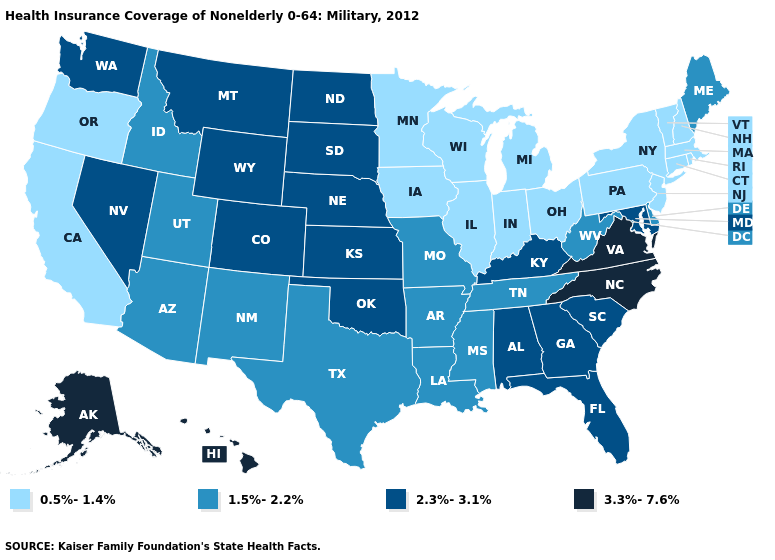Among the states that border Arkansas , does Oklahoma have the lowest value?
Short answer required. No. Does Michigan have the lowest value in the USA?
Be succinct. Yes. What is the value of Colorado?
Concise answer only. 2.3%-3.1%. Does the first symbol in the legend represent the smallest category?
Short answer required. Yes. What is the value of Ohio?
Quick response, please. 0.5%-1.4%. What is the value of Wisconsin?
Keep it brief. 0.5%-1.4%. Which states have the lowest value in the Northeast?
Keep it brief. Connecticut, Massachusetts, New Hampshire, New Jersey, New York, Pennsylvania, Rhode Island, Vermont. What is the value of Michigan?
Keep it brief. 0.5%-1.4%. Which states have the lowest value in the USA?
Quick response, please. California, Connecticut, Illinois, Indiana, Iowa, Massachusetts, Michigan, Minnesota, New Hampshire, New Jersey, New York, Ohio, Oregon, Pennsylvania, Rhode Island, Vermont, Wisconsin. Which states have the lowest value in the West?
Keep it brief. California, Oregon. What is the value of Utah?
Short answer required. 1.5%-2.2%. Name the states that have a value in the range 2.3%-3.1%?
Answer briefly. Alabama, Colorado, Florida, Georgia, Kansas, Kentucky, Maryland, Montana, Nebraska, Nevada, North Dakota, Oklahoma, South Carolina, South Dakota, Washington, Wyoming. What is the value of Alabama?
Give a very brief answer. 2.3%-3.1%. Does Maryland have the lowest value in the South?
Concise answer only. No. What is the lowest value in states that border North Dakota?
Concise answer only. 0.5%-1.4%. 